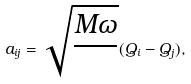<formula> <loc_0><loc_0><loc_500><loc_500>a _ { i j } = \sqrt { \frac { M \omega } { } } ( Q _ { i } - Q _ { j } ) ,</formula> 